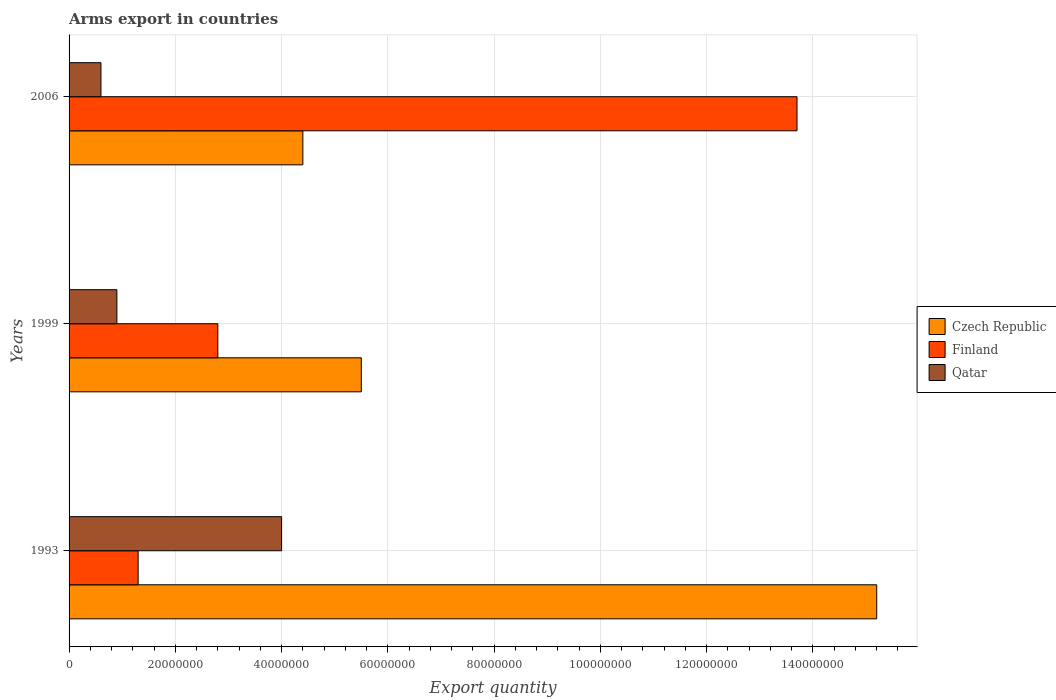How many different coloured bars are there?
Ensure brevity in your answer.  3. Are the number of bars per tick equal to the number of legend labels?
Give a very brief answer. Yes. How many bars are there on the 1st tick from the bottom?
Give a very brief answer. 3. What is the total arms export in Czech Republic in 2006?
Ensure brevity in your answer.  4.40e+07. Across all years, what is the maximum total arms export in Finland?
Make the answer very short. 1.37e+08. Across all years, what is the minimum total arms export in Finland?
Ensure brevity in your answer.  1.30e+07. What is the total total arms export in Czech Republic in the graph?
Your answer should be very brief. 2.51e+08. What is the difference between the total arms export in Qatar in 1999 and that in 2006?
Offer a terse response. 3.00e+06. What is the difference between the total arms export in Finland in 2006 and the total arms export in Qatar in 1999?
Keep it short and to the point. 1.28e+08. What is the average total arms export in Qatar per year?
Provide a short and direct response. 1.83e+07. In the year 1993, what is the difference between the total arms export in Finland and total arms export in Czech Republic?
Provide a short and direct response. -1.39e+08. What is the ratio of the total arms export in Finland in 1993 to that in 2006?
Ensure brevity in your answer.  0.09. Is the difference between the total arms export in Finland in 1999 and 2006 greater than the difference between the total arms export in Czech Republic in 1999 and 2006?
Your answer should be very brief. No. What is the difference between the highest and the second highest total arms export in Qatar?
Offer a very short reply. 3.10e+07. What is the difference between the highest and the lowest total arms export in Qatar?
Your answer should be compact. 3.40e+07. In how many years, is the total arms export in Qatar greater than the average total arms export in Qatar taken over all years?
Provide a succinct answer. 1. Is the sum of the total arms export in Czech Republic in 1999 and 2006 greater than the maximum total arms export in Qatar across all years?
Your answer should be very brief. Yes. What does the 3rd bar from the bottom in 1999 represents?
Provide a short and direct response. Qatar. Are all the bars in the graph horizontal?
Provide a succinct answer. Yes. How many years are there in the graph?
Make the answer very short. 3. Does the graph contain any zero values?
Provide a short and direct response. No. What is the title of the graph?
Make the answer very short. Arms export in countries. Does "Papua New Guinea" appear as one of the legend labels in the graph?
Provide a short and direct response. No. What is the label or title of the X-axis?
Your answer should be very brief. Export quantity. What is the Export quantity in Czech Republic in 1993?
Offer a terse response. 1.52e+08. What is the Export quantity of Finland in 1993?
Your response must be concise. 1.30e+07. What is the Export quantity in Qatar in 1993?
Your response must be concise. 4.00e+07. What is the Export quantity of Czech Republic in 1999?
Give a very brief answer. 5.50e+07. What is the Export quantity of Finland in 1999?
Your answer should be very brief. 2.80e+07. What is the Export quantity of Qatar in 1999?
Your answer should be very brief. 9.00e+06. What is the Export quantity in Czech Republic in 2006?
Your answer should be very brief. 4.40e+07. What is the Export quantity in Finland in 2006?
Offer a terse response. 1.37e+08. Across all years, what is the maximum Export quantity in Czech Republic?
Give a very brief answer. 1.52e+08. Across all years, what is the maximum Export quantity in Finland?
Offer a very short reply. 1.37e+08. Across all years, what is the maximum Export quantity in Qatar?
Give a very brief answer. 4.00e+07. Across all years, what is the minimum Export quantity of Czech Republic?
Offer a very short reply. 4.40e+07. Across all years, what is the minimum Export quantity in Finland?
Provide a short and direct response. 1.30e+07. Across all years, what is the minimum Export quantity in Qatar?
Your answer should be compact. 6.00e+06. What is the total Export quantity of Czech Republic in the graph?
Provide a succinct answer. 2.51e+08. What is the total Export quantity in Finland in the graph?
Offer a very short reply. 1.78e+08. What is the total Export quantity in Qatar in the graph?
Provide a succinct answer. 5.50e+07. What is the difference between the Export quantity in Czech Republic in 1993 and that in 1999?
Your answer should be very brief. 9.70e+07. What is the difference between the Export quantity of Finland in 1993 and that in 1999?
Your answer should be very brief. -1.50e+07. What is the difference between the Export quantity in Qatar in 1993 and that in 1999?
Ensure brevity in your answer.  3.10e+07. What is the difference between the Export quantity in Czech Republic in 1993 and that in 2006?
Provide a short and direct response. 1.08e+08. What is the difference between the Export quantity of Finland in 1993 and that in 2006?
Ensure brevity in your answer.  -1.24e+08. What is the difference between the Export quantity of Qatar in 1993 and that in 2006?
Ensure brevity in your answer.  3.40e+07. What is the difference between the Export quantity in Czech Republic in 1999 and that in 2006?
Offer a very short reply. 1.10e+07. What is the difference between the Export quantity of Finland in 1999 and that in 2006?
Your answer should be compact. -1.09e+08. What is the difference between the Export quantity in Czech Republic in 1993 and the Export quantity in Finland in 1999?
Make the answer very short. 1.24e+08. What is the difference between the Export quantity in Czech Republic in 1993 and the Export quantity in Qatar in 1999?
Provide a succinct answer. 1.43e+08. What is the difference between the Export quantity of Czech Republic in 1993 and the Export quantity of Finland in 2006?
Your answer should be very brief. 1.50e+07. What is the difference between the Export quantity in Czech Republic in 1993 and the Export quantity in Qatar in 2006?
Ensure brevity in your answer.  1.46e+08. What is the difference between the Export quantity of Czech Republic in 1999 and the Export quantity of Finland in 2006?
Provide a short and direct response. -8.20e+07. What is the difference between the Export quantity in Czech Republic in 1999 and the Export quantity in Qatar in 2006?
Provide a succinct answer. 4.90e+07. What is the difference between the Export quantity in Finland in 1999 and the Export quantity in Qatar in 2006?
Keep it short and to the point. 2.20e+07. What is the average Export quantity in Czech Republic per year?
Your answer should be very brief. 8.37e+07. What is the average Export quantity in Finland per year?
Keep it short and to the point. 5.93e+07. What is the average Export quantity of Qatar per year?
Give a very brief answer. 1.83e+07. In the year 1993, what is the difference between the Export quantity in Czech Republic and Export quantity in Finland?
Your answer should be compact. 1.39e+08. In the year 1993, what is the difference between the Export quantity in Czech Republic and Export quantity in Qatar?
Your response must be concise. 1.12e+08. In the year 1993, what is the difference between the Export quantity in Finland and Export quantity in Qatar?
Keep it short and to the point. -2.70e+07. In the year 1999, what is the difference between the Export quantity in Czech Republic and Export quantity in Finland?
Your answer should be compact. 2.70e+07. In the year 1999, what is the difference between the Export quantity of Czech Republic and Export quantity of Qatar?
Keep it short and to the point. 4.60e+07. In the year 1999, what is the difference between the Export quantity in Finland and Export quantity in Qatar?
Give a very brief answer. 1.90e+07. In the year 2006, what is the difference between the Export quantity of Czech Republic and Export quantity of Finland?
Keep it short and to the point. -9.30e+07. In the year 2006, what is the difference between the Export quantity in Czech Republic and Export quantity in Qatar?
Provide a succinct answer. 3.80e+07. In the year 2006, what is the difference between the Export quantity of Finland and Export quantity of Qatar?
Offer a terse response. 1.31e+08. What is the ratio of the Export quantity of Czech Republic in 1993 to that in 1999?
Your response must be concise. 2.76. What is the ratio of the Export quantity of Finland in 1993 to that in 1999?
Provide a short and direct response. 0.46. What is the ratio of the Export quantity in Qatar in 1993 to that in 1999?
Make the answer very short. 4.44. What is the ratio of the Export quantity of Czech Republic in 1993 to that in 2006?
Offer a terse response. 3.45. What is the ratio of the Export quantity of Finland in 1993 to that in 2006?
Offer a terse response. 0.09. What is the ratio of the Export quantity in Finland in 1999 to that in 2006?
Keep it short and to the point. 0.2. What is the difference between the highest and the second highest Export quantity of Czech Republic?
Keep it short and to the point. 9.70e+07. What is the difference between the highest and the second highest Export quantity in Finland?
Offer a very short reply. 1.09e+08. What is the difference between the highest and the second highest Export quantity of Qatar?
Make the answer very short. 3.10e+07. What is the difference between the highest and the lowest Export quantity in Czech Republic?
Give a very brief answer. 1.08e+08. What is the difference between the highest and the lowest Export quantity in Finland?
Offer a terse response. 1.24e+08. What is the difference between the highest and the lowest Export quantity in Qatar?
Make the answer very short. 3.40e+07. 